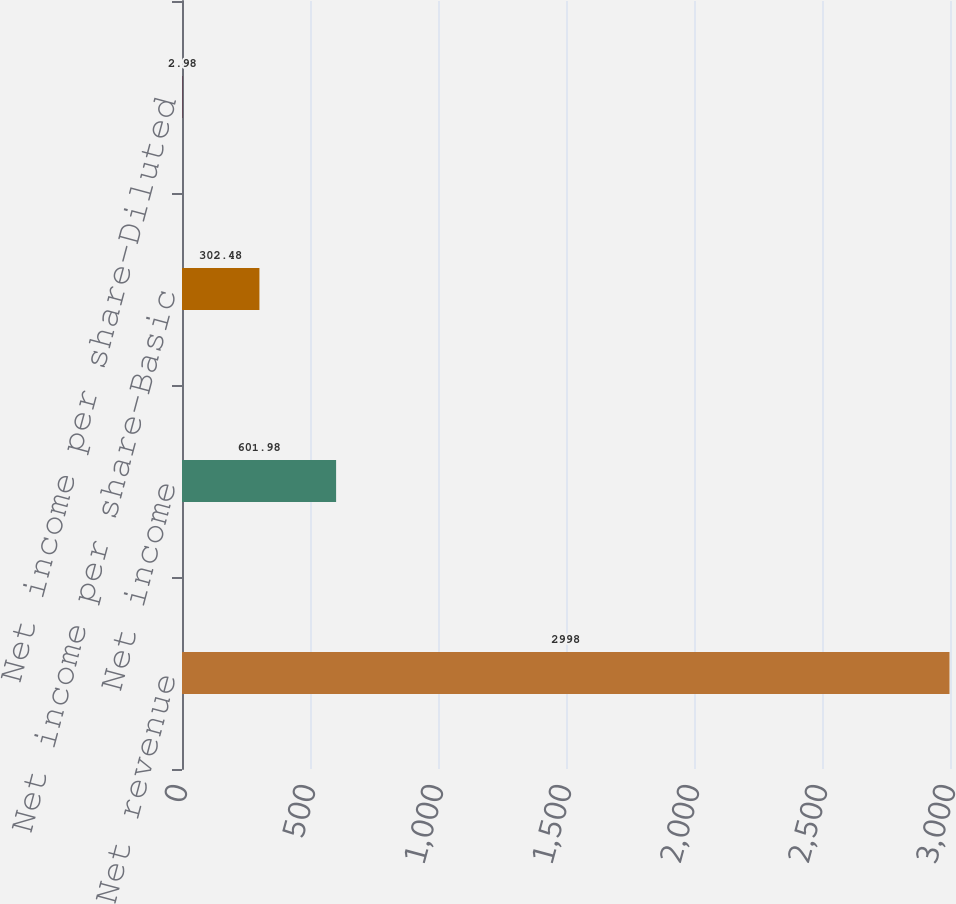<chart> <loc_0><loc_0><loc_500><loc_500><bar_chart><fcel>Net revenue<fcel>Net income<fcel>Net income per share-Basic<fcel>Net income per share-Diluted<nl><fcel>2998<fcel>601.98<fcel>302.48<fcel>2.98<nl></chart> 